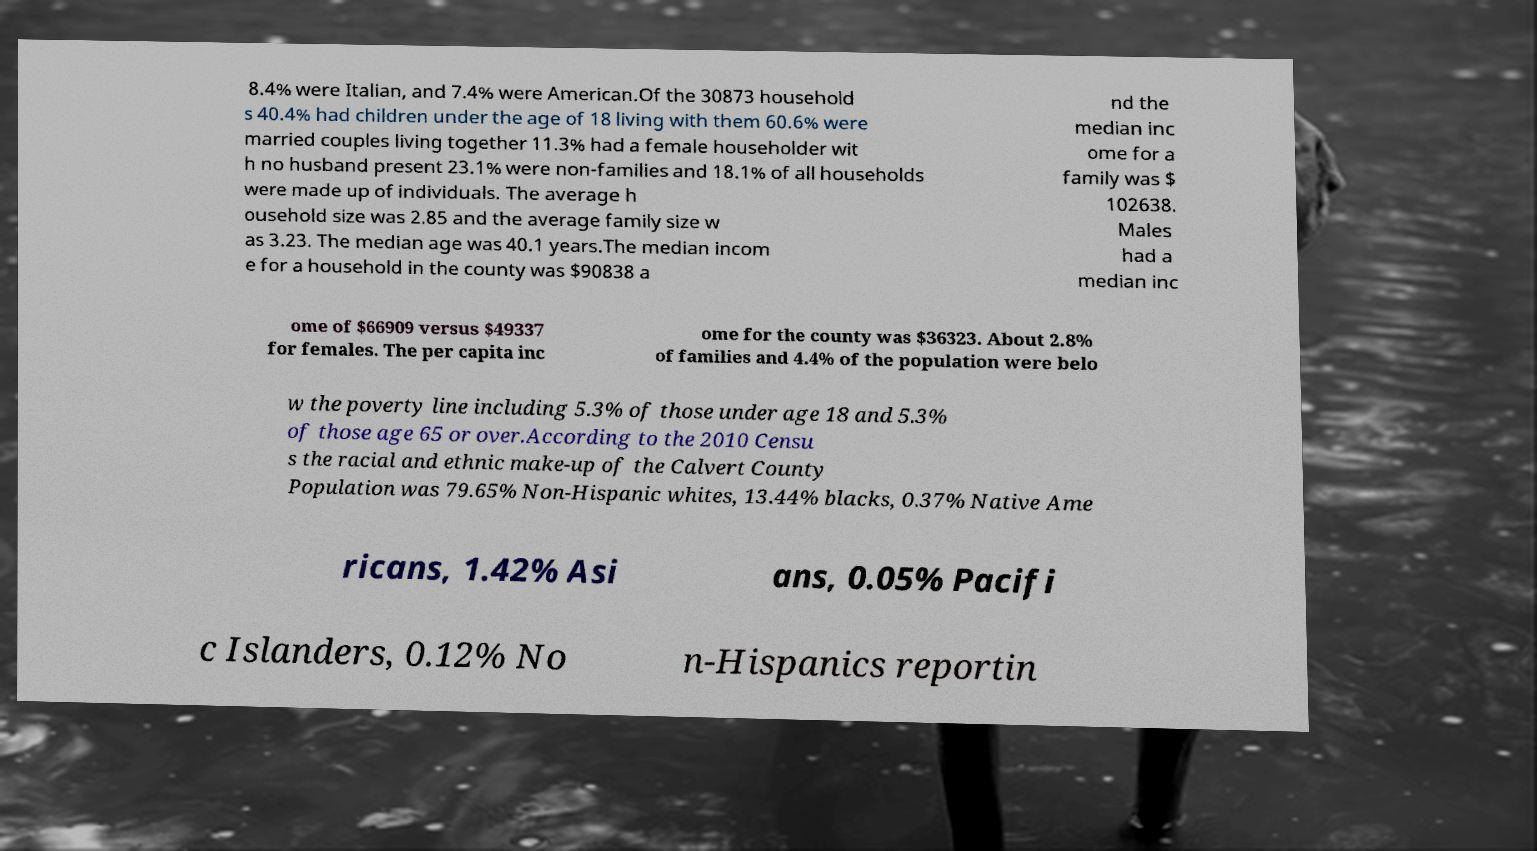Could you assist in decoding the text presented in this image and type it out clearly? 8.4% were Italian, and 7.4% were American.Of the 30873 household s 40.4% had children under the age of 18 living with them 60.6% were married couples living together 11.3% had a female householder wit h no husband present 23.1% were non-families and 18.1% of all households were made up of individuals. The average h ousehold size was 2.85 and the average family size w as 3.23. The median age was 40.1 years.The median incom e for a household in the county was $90838 a nd the median inc ome for a family was $ 102638. Males had a median inc ome of $66909 versus $49337 for females. The per capita inc ome for the county was $36323. About 2.8% of families and 4.4% of the population were belo w the poverty line including 5.3% of those under age 18 and 5.3% of those age 65 or over.According to the 2010 Censu s the racial and ethnic make-up of the Calvert County Population was 79.65% Non-Hispanic whites, 13.44% blacks, 0.37% Native Ame ricans, 1.42% Asi ans, 0.05% Pacifi c Islanders, 0.12% No n-Hispanics reportin 